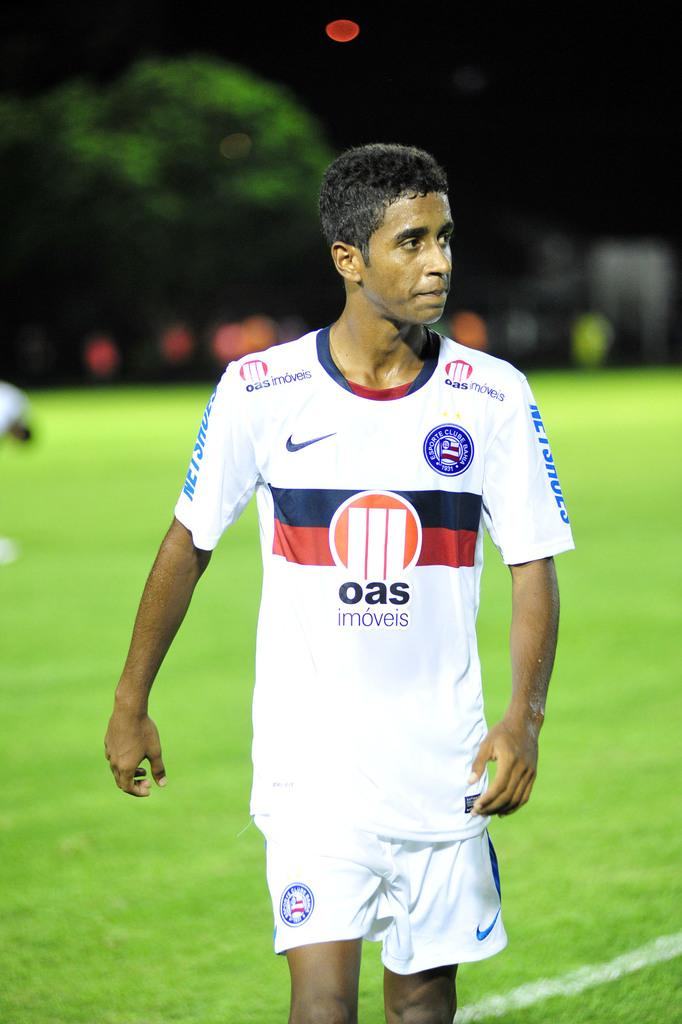<image>
Write a terse but informative summary of the picture. A man is wearing a white jersey that reads "oas" on the front. 